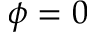Convert formula to latex. <formula><loc_0><loc_0><loc_500><loc_500>\phi = 0</formula> 